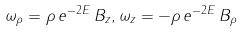<formula> <loc_0><loc_0><loc_500><loc_500>\omega _ { \rho } = \rho \, e ^ { - 2 E } \, B _ { z } , \omega _ { z } = - \rho \, e ^ { - 2 E } \, B _ { \rho }</formula> 